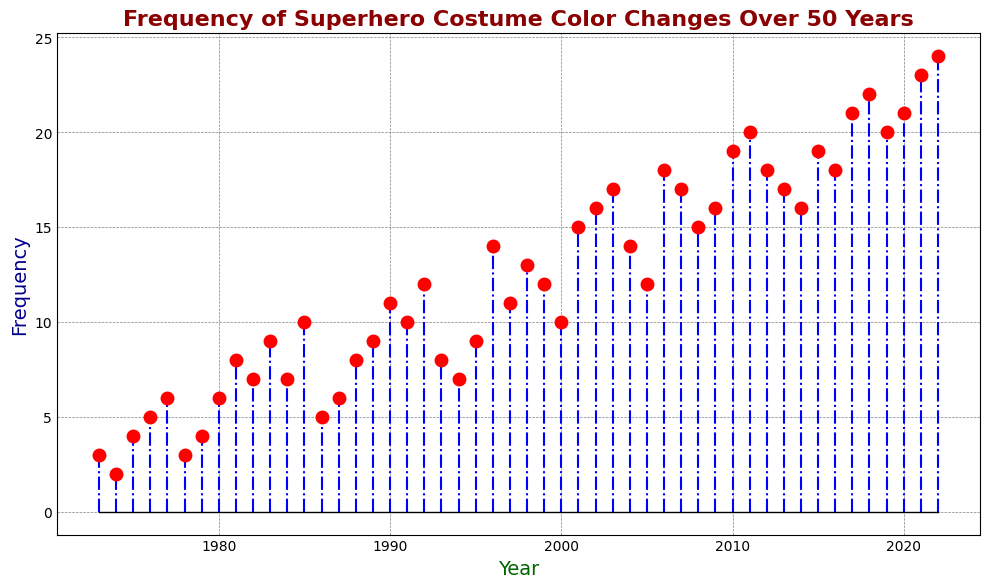What is the highest frequency of superhero costume color changes in the given timeframe? The highest point on the y-axis of the stem plot represents the peak frequency. Looking at the plot, the highest frequency recorded is found at the year 2022 with a frequency of 24.
Answer: 24 Which year had the lowest frequency of superhero costume color changes? To find the minimum value, we look for the shortest red marker on the plot. The lowest frequency, which is 2, occurred in the year 1974.
Answer: 1974 Is there a general trend of increasing or decreasing frequency over the 50 years? By observing the overall direction of the stem plot, it appears that the frequency of superhero costume color changes has an upward trend, as the markers and lines generally move higher on the y-axis as the years progress.
Answer: Increasing What is the average frequency of superhero costume color changes from 1980 to 1990? Identify the frequencies for each year between 1980 and 1990: [6, 8, 7, 9, 7, 10, 5, 6, 8, 9, 11]. Sum these values (6+8+7+9+7+10+5+6+8+9+11=86) and divide by the number of values (11). The average frequency is 86/11 ≈ 7.82.
Answer: 7.82 Which year experienced the most significant increase in frequency compared to the previous year? By comparing the differences between consecutive years, the largest increase is from 1995 to 1996 where the frequency jumps from 9 to 14, an increase of 5.
Answer: 1996 How many years had frequencies above 15? Count the number of red markers that have a frequency greater than 15. The frequencies above 15 occur in the years: 2002, 2003, 2006, 2007, 2009, 2010, 2011, 2012, 2013, 2014, 2015, 2016, 2017, 2018, 2019, 2020, 2021, 2022. There are 18 such years.
Answer: 18 What is the median frequency of superhero costume color changes for the entire period? The median is the middle value in the sorted frequency list. The sorted frequencies are: [2, 3, 3, 4, 4, 5, 5, 6, 6, 6, 7, 7, 7, 8, 8, 8, 8, 9, 9, 9, 10, 10, 10, 11, 11, 12, 12, 12, 13, 14, 14, 15, 15, 16, 16, 16, 17, 17, 17, 18, 18, 18, 19, 19, 20, 20, 21, 21, 22, 23, 24]. With 50 values, the median is the average of the 25th and 26th values: (10+11)/2 = 10.5.
Answer: 10.5 